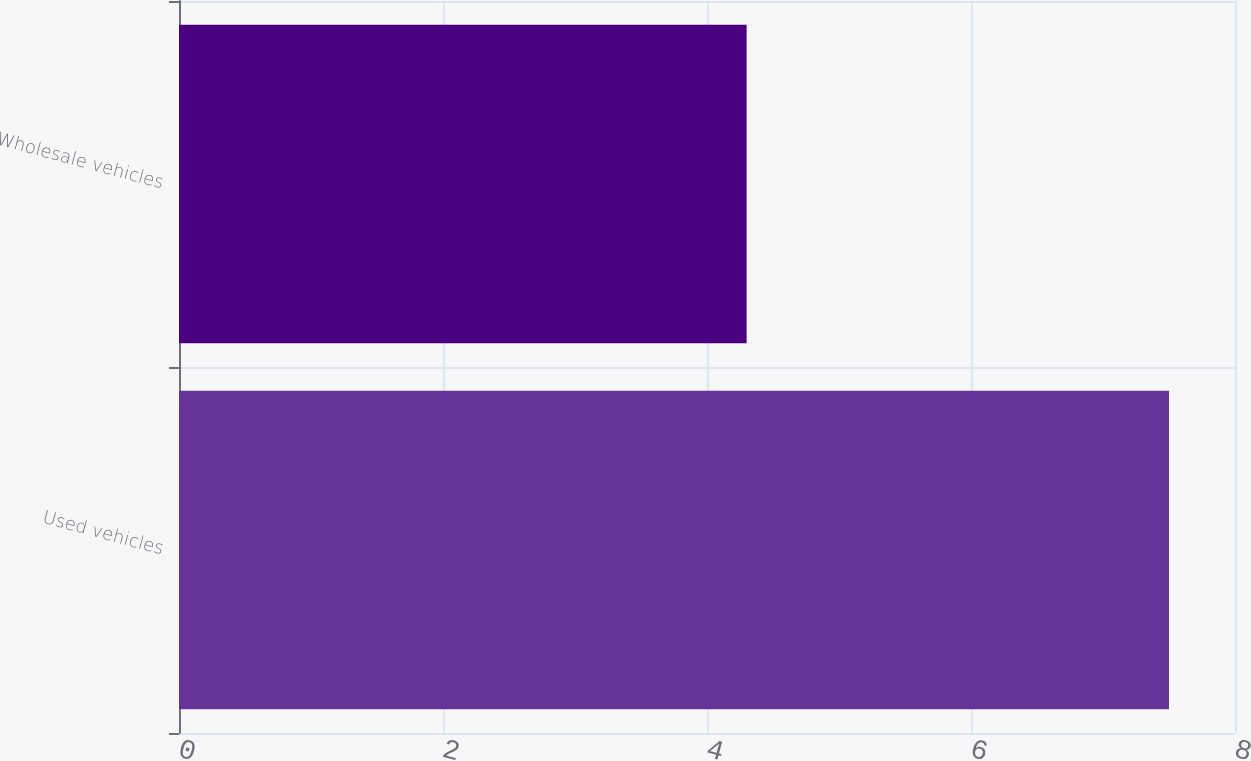<chart> <loc_0><loc_0><loc_500><loc_500><bar_chart><fcel>Used vehicles<fcel>Wholesale vehicles<nl><fcel>7.5<fcel>4.3<nl></chart> 